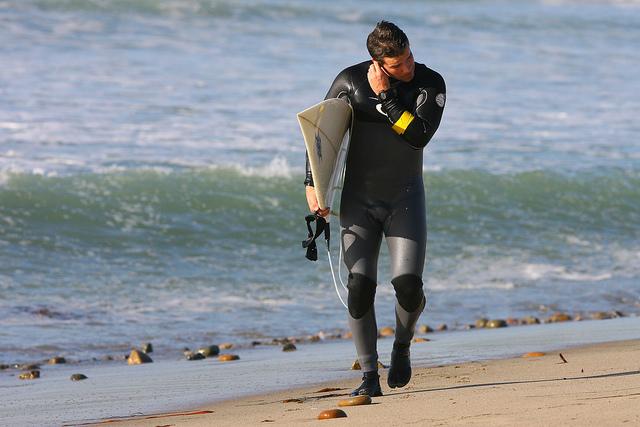Is this man a professional surfer?
Short answer required. Yes. What is this man going to do?
Quick response, please. Surf. What color is the man wearing?
Answer briefly. Black. 